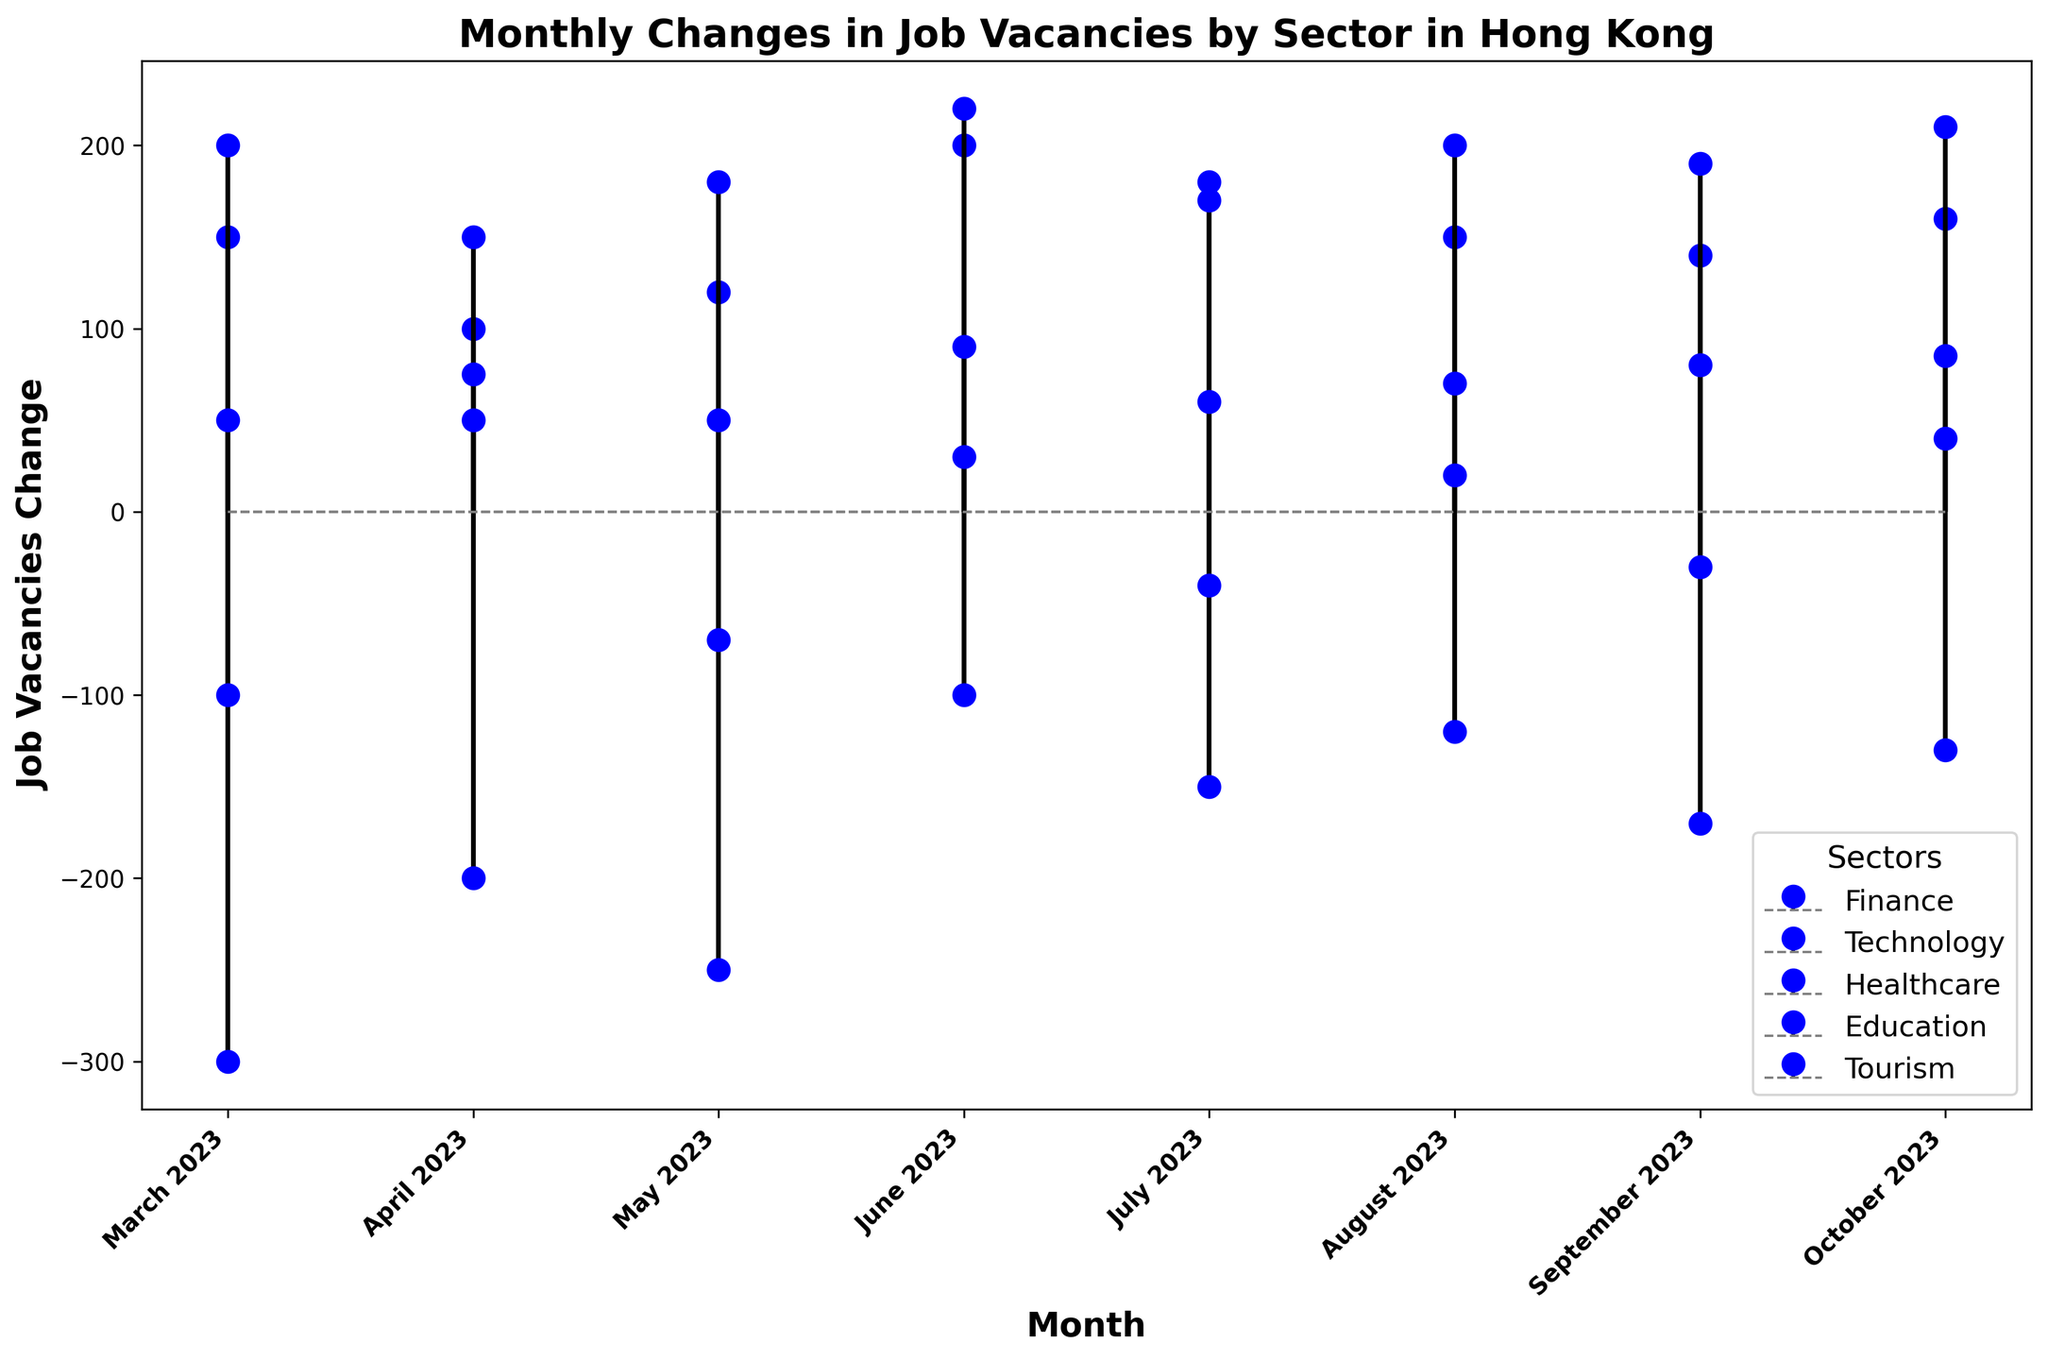Which sector had the largest increase in job vacancies in June 2023? Look for the sector with the highest stem plot point above the baseline in June 2023. Healthcare had the highest increase with a value of 220.
Answer: Healthcare Which sector saw the most consistent increase in job vacancies from March to October 2023? Consistency implies looking at sectors where the job vacancies values are generally positive and increasing or consistently positive over the months. Technology and Healthcare generally show consistent increases, but Healthcare has the strongest consistent increase.
Answer: Healthcare Which month saw the smallest decrease in job vacancies for the Finance sector? Compare the negative values for the Finance sector across all months. The smallest decrease (least negative) was -100 in June 2023.
Answer: June 2023 In which month did the Tourism sector switch from a negative change to a positive change in job vacancies? Identify the month where the Tourism sector's stem plot point goes from below (negative) to above (positive) the baseline. This change occurs between March and April 2023.
Answer: April 2023 What is the total change in job vacancies for Technology from March to October 2023? Sum the job vacancies in the Technology sector over all the months. That is 150 + 100 + 120 + 200 + 180 + 150 + 140 + 160 = 1200.
Answer: 1200 Which sector had the largest variation in job vacancy changes throughout the months? Variation implies the range; find the sector with the highest range between the maximum and minimum values. Calculate the range for each sector. Finance has the widest range, from -300 to -100, which is the largest variation.
Answer: Finance How did job vacancies in the Education sector change from September to October 2023? Compare the values of job vacancies in the Education sector between September and October 2023, which are 80 and 85 respectively. The change is 85 - 80 = 5.
Answer: Increased by 5 What was the highest increase in job vacancies observed in any given sector and month? Look for the highest positive value in any sector and month. The highest increase is in Healthcare in June 2023, with a value of 220.
Answer: 220 Which sector had the least job vacancies change in July 2023? Compare the values for each sector in July 2023. Education had the smallest change of 60.
Answer: Education Between Finance and Tourism, which sector showed more frequent positive changes? Check the monthly changes and count positive values for both sectors. Finance has no positive changes; Tourism has positive changes in April, June, August, and October. Therefore, Tourism has more frequent positive changes.
Answer: Tourism 